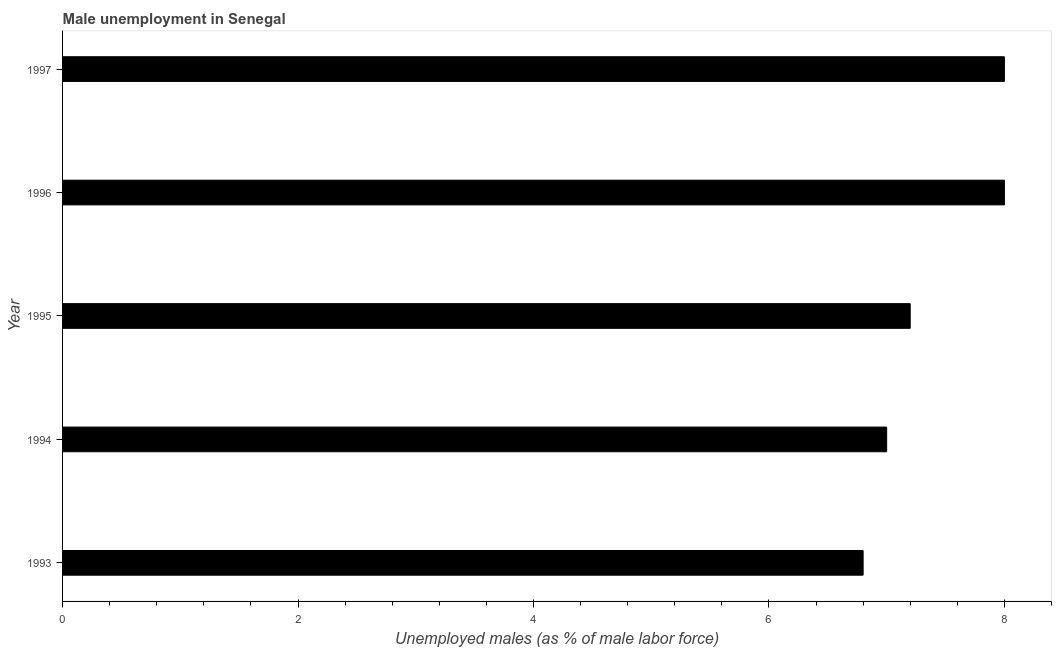Does the graph contain any zero values?
Ensure brevity in your answer.  No. Does the graph contain grids?
Your response must be concise. No. What is the title of the graph?
Make the answer very short. Male unemployment in Senegal. What is the label or title of the X-axis?
Offer a terse response. Unemployed males (as % of male labor force). What is the label or title of the Y-axis?
Ensure brevity in your answer.  Year. What is the unemployed males population in 1993?
Ensure brevity in your answer.  6.8. Across all years, what is the maximum unemployed males population?
Your response must be concise. 8. Across all years, what is the minimum unemployed males population?
Ensure brevity in your answer.  6.8. What is the sum of the unemployed males population?
Keep it short and to the point. 37. What is the difference between the unemployed males population in 1995 and 1996?
Offer a terse response. -0.8. What is the median unemployed males population?
Keep it short and to the point. 7.2. What is the ratio of the unemployed males population in 1995 to that in 1997?
Your answer should be compact. 0.9. Is the difference between the unemployed males population in 1995 and 1996 greater than the difference between any two years?
Offer a terse response. No. Is the sum of the unemployed males population in 1993 and 1996 greater than the maximum unemployed males population across all years?
Your response must be concise. Yes. How many bars are there?
Your answer should be compact. 5. Are all the bars in the graph horizontal?
Keep it short and to the point. Yes. What is the difference between two consecutive major ticks on the X-axis?
Your answer should be compact. 2. Are the values on the major ticks of X-axis written in scientific E-notation?
Provide a succinct answer. No. What is the Unemployed males (as % of male labor force) in 1993?
Give a very brief answer. 6.8. What is the Unemployed males (as % of male labor force) in 1995?
Your response must be concise. 7.2. What is the Unemployed males (as % of male labor force) of 1996?
Give a very brief answer. 8. What is the difference between the Unemployed males (as % of male labor force) in 1993 and 1995?
Give a very brief answer. -0.4. What is the difference between the Unemployed males (as % of male labor force) in 1993 and 1997?
Offer a terse response. -1.2. What is the difference between the Unemployed males (as % of male labor force) in 1994 and 1996?
Your answer should be compact. -1. What is the difference between the Unemployed males (as % of male labor force) in 1996 and 1997?
Ensure brevity in your answer.  0. What is the ratio of the Unemployed males (as % of male labor force) in 1993 to that in 1995?
Your answer should be very brief. 0.94. What is the ratio of the Unemployed males (as % of male labor force) in 1993 to that in 1997?
Provide a succinct answer. 0.85. What is the ratio of the Unemployed males (as % of male labor force) in 1994 to that in 1995?
Make the answer very short. 0.97. What is the ratio of the Unemployed males (as % of male labor force) in 1994 to that in 1997?
Your answer should be compact. 0.88. 